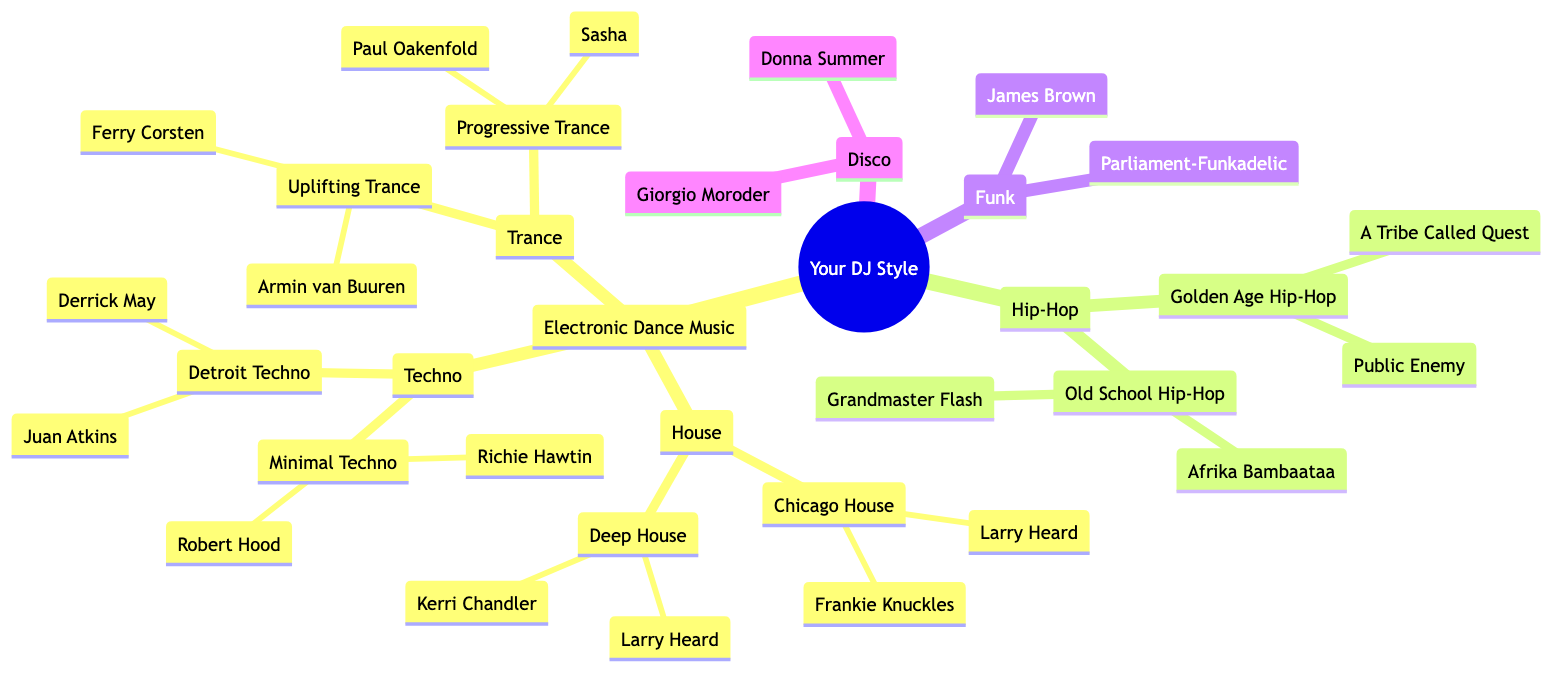What are the main categories of musical influences in the diagram? The main categories are Electronic Dance Music, Hip-Hop, Funk, and Disco. These are the highest-level nodes directly under the root node "Your DJ Style".
Answer: Electronic Dance Music, Hip-Hop, Funk, Disco How many sub-genres are under Electronic Dance Music? There are three sub-genres listed under Electronic Dance Music: House, Techno, and Trance. Each of these genres has its own further sub-categories as well.
Answer: 3 Who is an artist associated with Deep House? Deep House has two listed artists: Kerri Chandler and Larry Heard. Either can be an acceptable answer to the question.
Answer: Kerri Chandler What genre does Grandmaster Flash belong to? Grandmaster Flash is associated with Old School Hip-Hop, which falls under the Hip-Hop category in the diagram.
Answer: Old School Hip-Hop Which genre has the artist Armin van Buuren? Armin van Buuren is listed under the sub-genre Uplifting Trance, which is itself a category of Trance within Electronic Dance Music.
Answer: Uplifting Trance Which artist is a representative of Detroit Techno? The artists listed for Detroit Techno are Juan Atkins and Derrick May, both of whom are recognized figures in this genre.
Answer: Juan Atkins What is the total number of artists listed under Funk? There are two artists listed under Funk: James Brown and Parliament-Funkadelic, making a total of two.
Answer: 2 What are the names of the artists associated with Progressive Trance? The artists associated with Progressive Trance are Paul Oakenfold and Sasha. Both are noted figures within this sub-genre of Trance.
Answer: Paul Oakenfold, Sasha Which genre features Donna Summer? Donna Summer is associated with the Disco genre, as indicated by her presence in the list of artists under that category.
Answer: Disco 